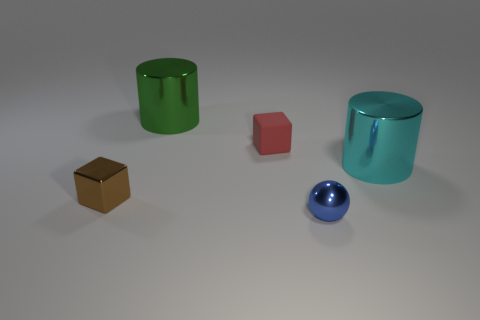Add 1 tiny red balls. How many objects exist? 6 Subtract all cylinders. How many objects are left? 3 Add 3 metallic balls. How many metallic balls are left? 4 Add 4 yellow rubber cylinders. How many yellow rubber cylinders exist? 4 Subtract 0 brown cylinders. How many objects are left? 5 Subtract all tiny shiny objects. Subtract all big yellow cylinders. How many objects are left? 3 